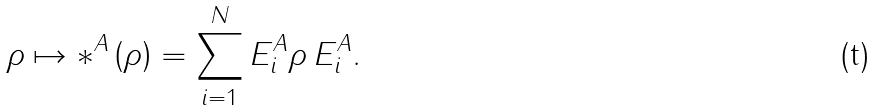<formula> <loc_0><loc_0><loc_500><loc_500>\rho \mapsto \mathcal { \Lambda } ^ { A } \left ( \rho \right ) = \sum _ { i = 1 } ^ { N } E _ { i } ^ { A } \rho \, E _ { i } ^ { A } .</formula> 